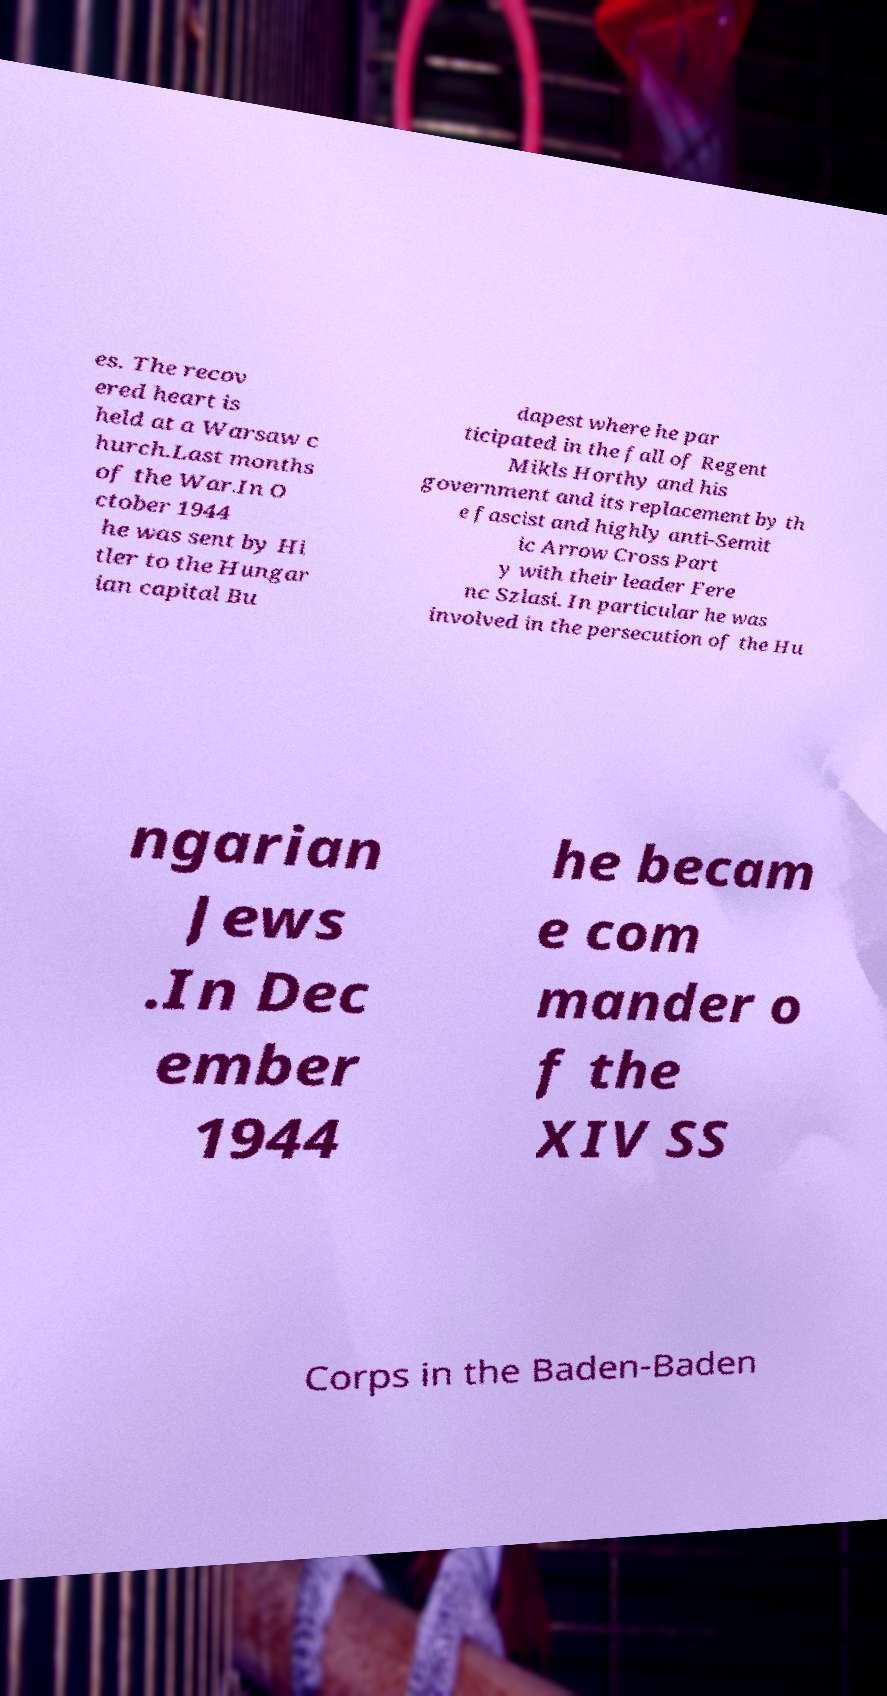Could you assist in decoding the text presented in this image and type it out clearly? es. The recov ered heart is held at a Warsaw c hurch.Last months of the War.In O ctober 1944 he was sent by Hi tler to the Hungar ian capital Bu dapest where he par ticipated in the fall of Regent Mikls Horthy and his government and its replacement by th e fascist and highly anti-Semit ic Arrow Cross Part y with their leader Fere nc Szlasi. In particular he was involved in the persecution of the Hu ngarian Jews .In Dec ember 1944 he becam e com mander o f the XIV SS Corps in the Baden-Baden 